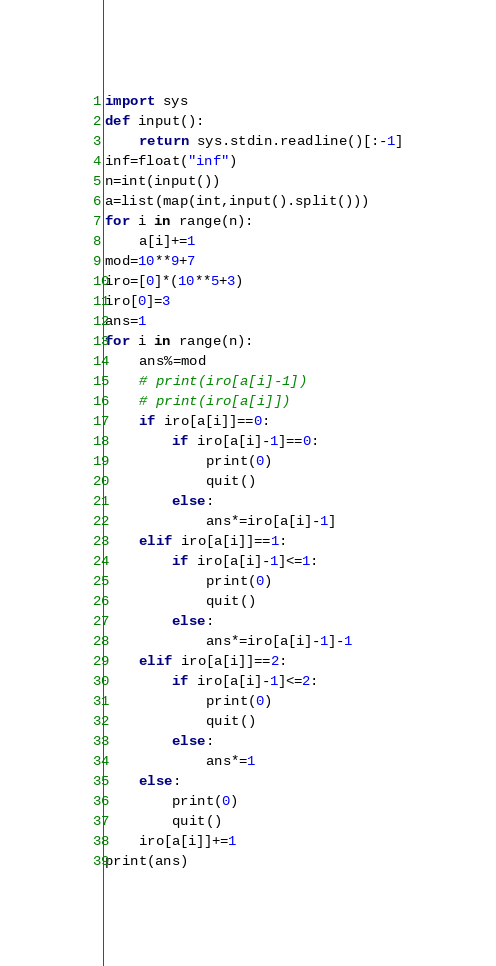<code> <loc_0><loc_0><loc_500><loc_500><_Python_>import sys
def input():
    return sys.stdin.readline()[:-1]
inf=float("inf")
n=int(input())
a=list(map(int,input().split()))
for i in range(n):
    a[i]+=1
mod=10**9+7
iro=[0]*(10**5+3)
iro[0]=3
ans=1
for i in range(n):
    ans%=mod
    # print(iro[a[i]-1])
    # print(iro[a[i]])
    if iro[a[i]]==0:
        if iro[a[i]-1]==0:
            print(0)
            quit()
        else:
            ans*=iro[a[i]-1]
    elif iro[a[i]]==1:
        if iro[a[i]-1]<=1:
            print(0)
            quit()
        else:
            ans*=iro[a[i]-1]-1
    elif iro[a[i]]==2:
        if iro[a[i]-1]<=2:
            print(0)
            quit()
        else:
            ans*=1
    else:
        print(0)
        quit()
    iro[a[i]]+=1
print(ans)
</code> 